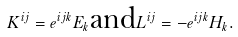Convert formula to latex. <formula><loc_0><loc_0><loc_500><loc_500>K ^ { i j } = e ^ { i j k } E _ { k } \text {and} L ^ { i j } = - e ^ { i j k } H _ { k } .</formula> 